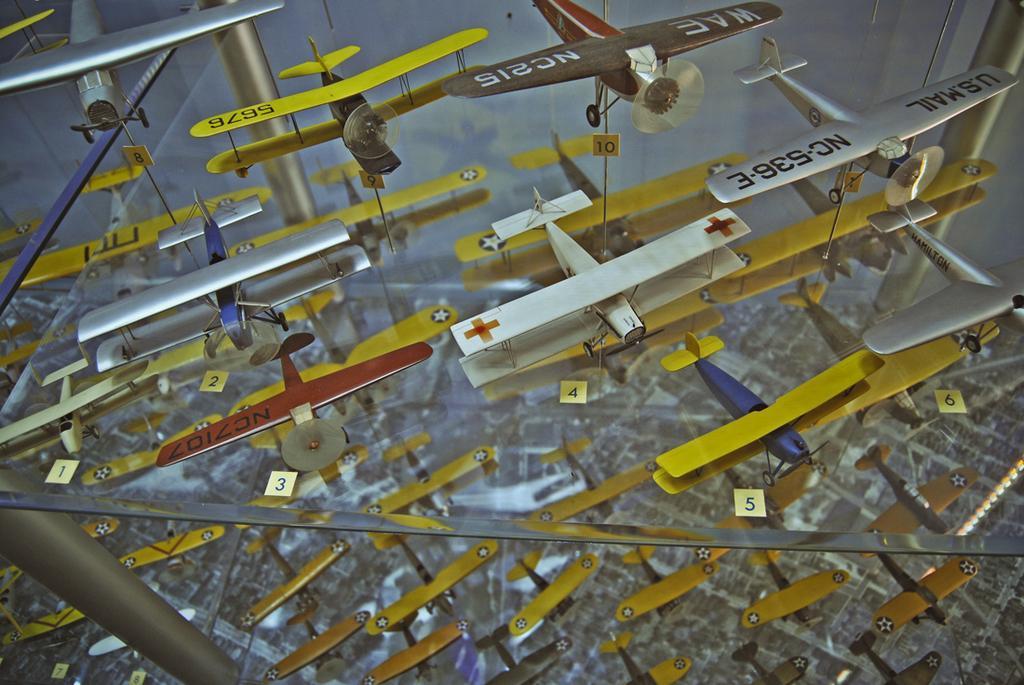Can you describe this image briefly? In this image we can see many airplanes on a glass table. 